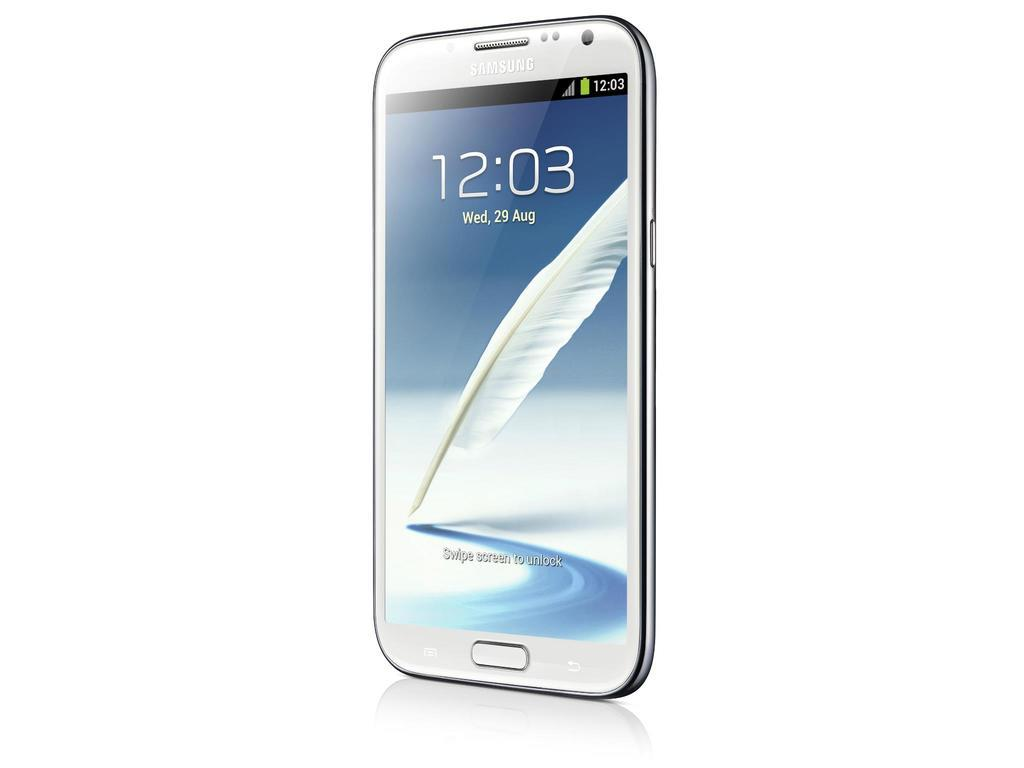<image>
Give a short and clear explanation of the subsequent image. A Samsung brand phone displays the time of 12:03. 